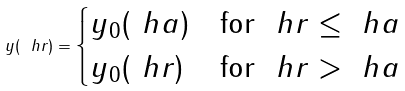Convert formula to latex. <formula><loc_0><loc_0><loc_500><loc_500>y ( \ h r ) = \begin{cases} y _ { 0 } ( \ h a ) & \text {for\ } \ h r \leq \ h a \\ y _ { 0 } ( \ h r ) & \text {for\ } \ h r > \ h a \end{cases}</formula> 